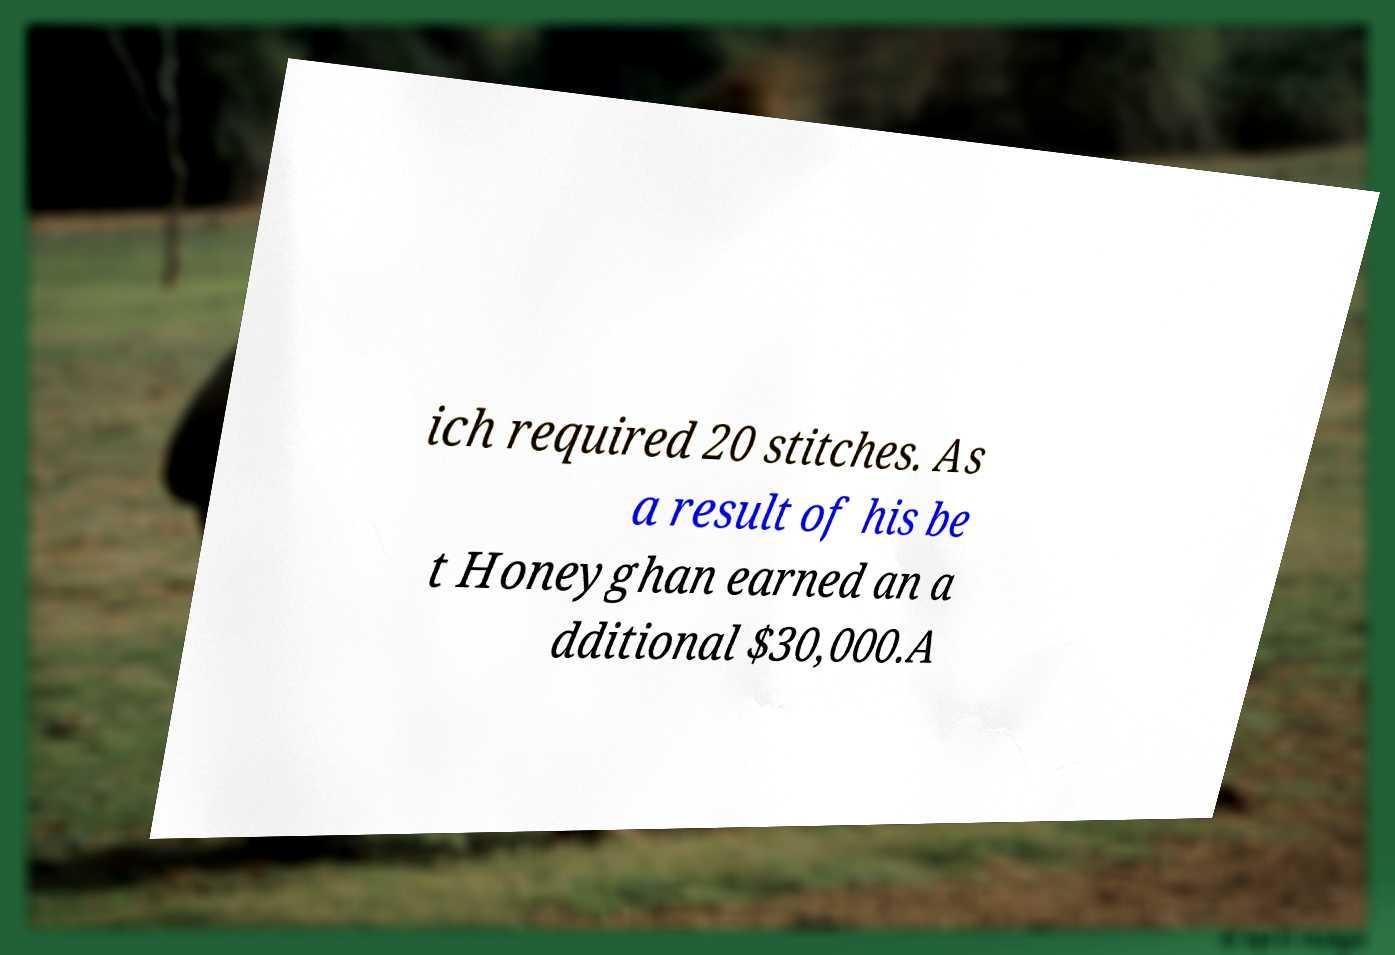Could you extract and type out the text from this image? ich required 20 stitches. As a result of his be t Honeyghan earned an a dditional $30,000.A 